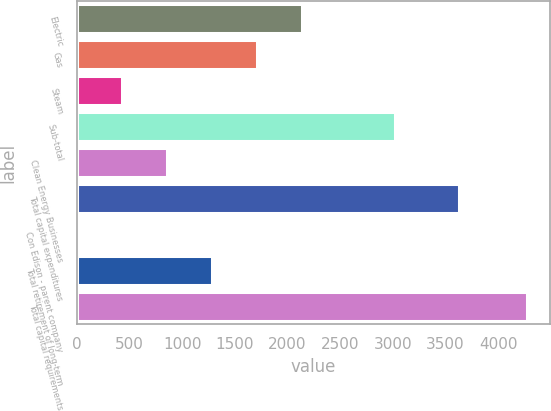Convert chart. <chart><loc_0><loc_0><loc_500><loc_500><bar_chart><fcel>Electric<fcel>Gas<fcel>Steam<fcel>Sub-total<fcel>Clean Energy Businesses<fcel>Total capital expenditures<fcel>Con Edison - parent company<fcel>Total retirement of long-term<fcel>Total capital requirements<nl><fcel>2140<fcel>1712.6<fcel>430.4<fcel>3016<fcel>857.8<fcel>3627<fcel>3<fcel>1285.2<fcel>4277<nl></chart> 